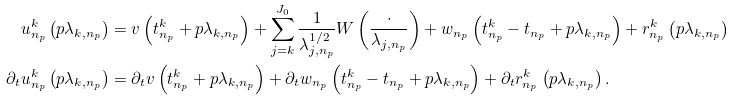<formula> <loc_0><loc_0><loc_500><loc_500>u _ { n _ { p } } ^ { k } \left ( p \lambda _ { k , n _ { p } } \right ) & = v \left ( t _ { n _ { p } } ^ { k } + p \lambda _ { k , n _ { p } } \right ) + \sum _ { j = k } ^ { J _ { 0 } } \frac { 1 } { \lambda _ { j , n _ { p } } ^ { 1 / 2 } } W \left ( \frac { \cdot } { \lambda _ { j , n _ { p } } } \right ) + w _ { n _ { p } } \left ( t _ { n _ { p } } ^ { k } - t _ { n _ { p } } + p \lambda _ { k , n _ { p } } \right ) + r _ { n _ { p } } ^ { k } \left ( p \lambda _ { k , n _ { p } } \right ) \\ \partial _ { t } u _ { n _ { p } } ^ { k } \left ( p \lambda _ { k , n _ { p } } \right ) & = \partial _ { t } v \left ( t _ { n _ { p } } ^ { k } + p \lambda _ { k , n _ { p } } \right ) + \partial _ { t } w _ { n _ { p } } \left ( t _ { n _ { p } } ^ { k } - t _ { n _ { p } } + p \lambda _ { k , n _ { p } } \right ) + \partial _ { t } r _ { n _ { p } } ^ { k } \left ( p \lambda _ { k , n _ { p } } \right ) .</formula> 